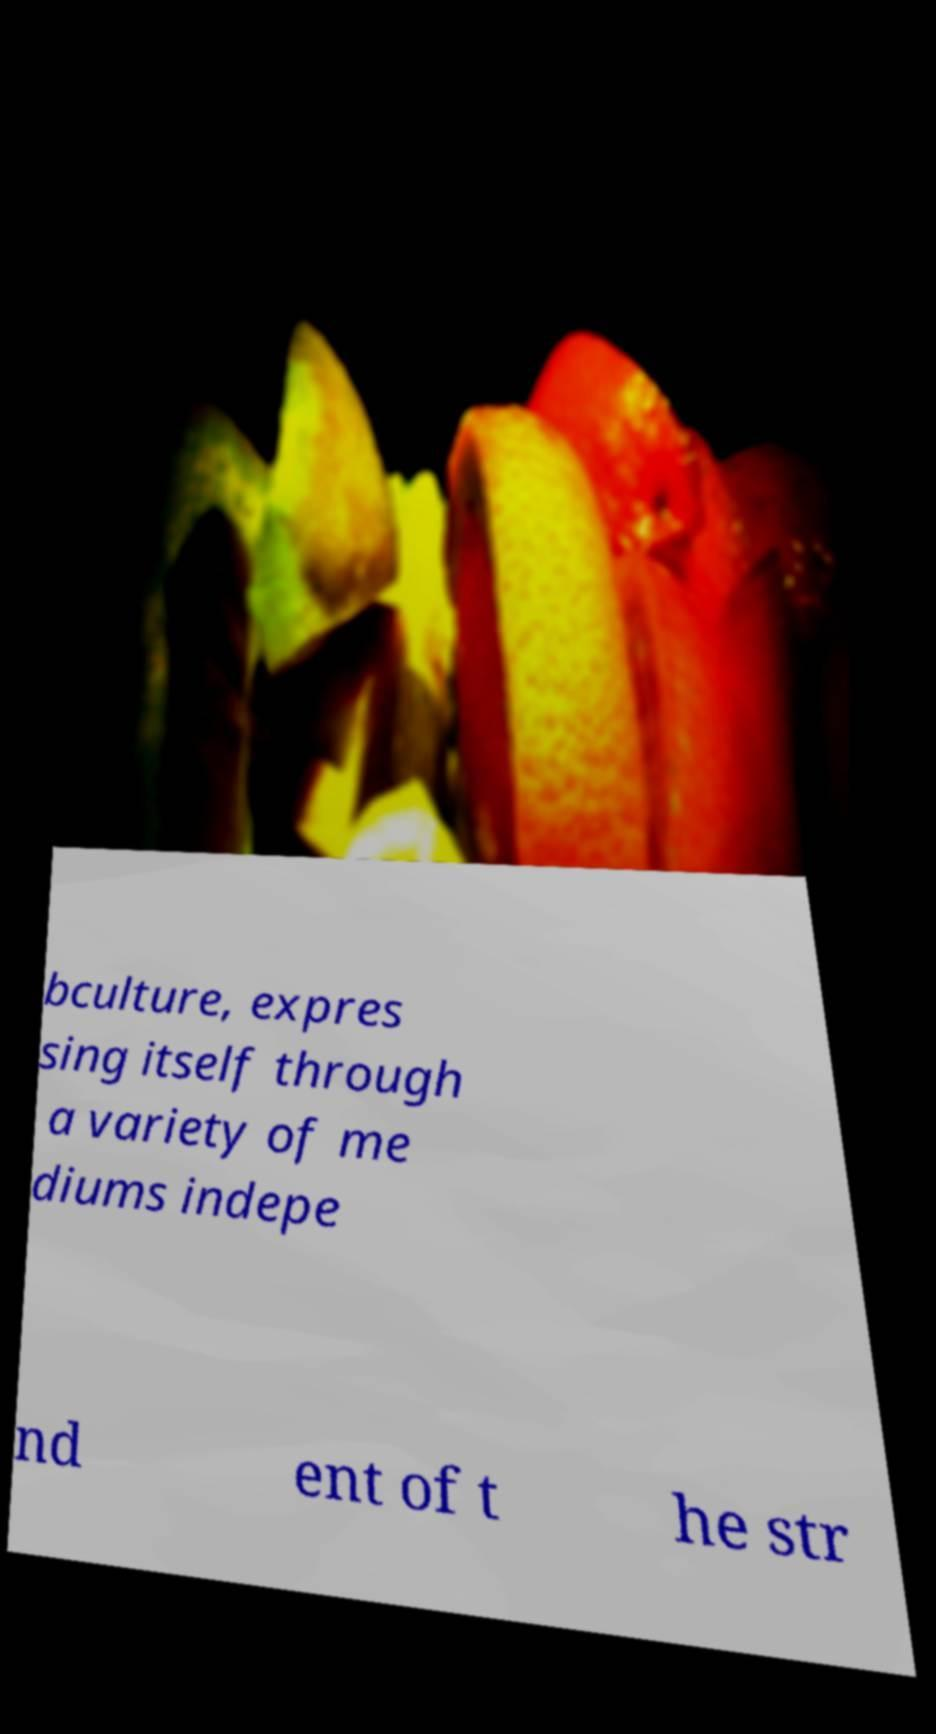Could you extract and type out the text from this image? bculture, expres sing itself through a variety of me diums indepe nd ent of t he str 